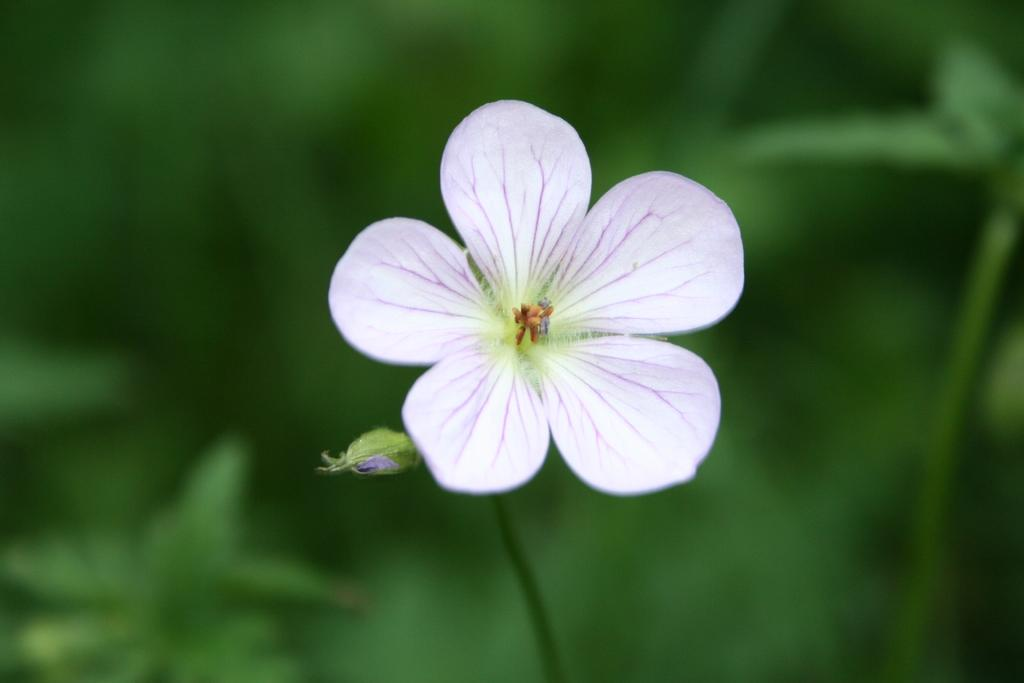Where was the image taken? The image was taken outdoors. What can be seen in the background of the image? The background of the image is green and slightly blurred. What is the main subject of the image? There is a flower in the middle of the image. What color is the flower? The flower is lilac in color. How many cacti are visible in the image? There are no cacti present in the image. What type of vehicles can be seen in the background of the image? There are no vehicles visible in the image; it is taken outdoors with a green and slightly blurred background. 